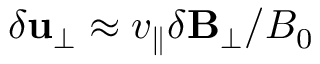<formula> <loc_0><loc_0><loc_500><loc_500>\delta u _ { \perp } \approx v _ { \| } \delta B _ { \perp } / B _ { 0 }</formula> 